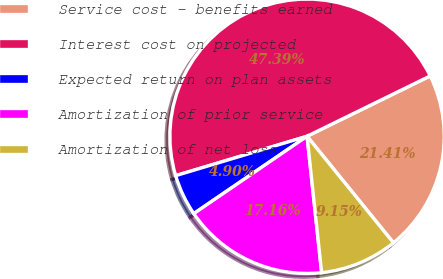Convert chart. <chart><loc_0><loc_0><loc_500><loc_500><pie_chart><fcel>Service cost - benefits earned<fcel>Interest cost on projected<fcel>Expected return on plan assets<fcel>Amortization of prior service<fcel>Amortization of net loss<nl><fcel>21.41%<fcel>47.39%<fcel>4.9%<fcel>17.16%<fcel>9.15%<nl></chart> 